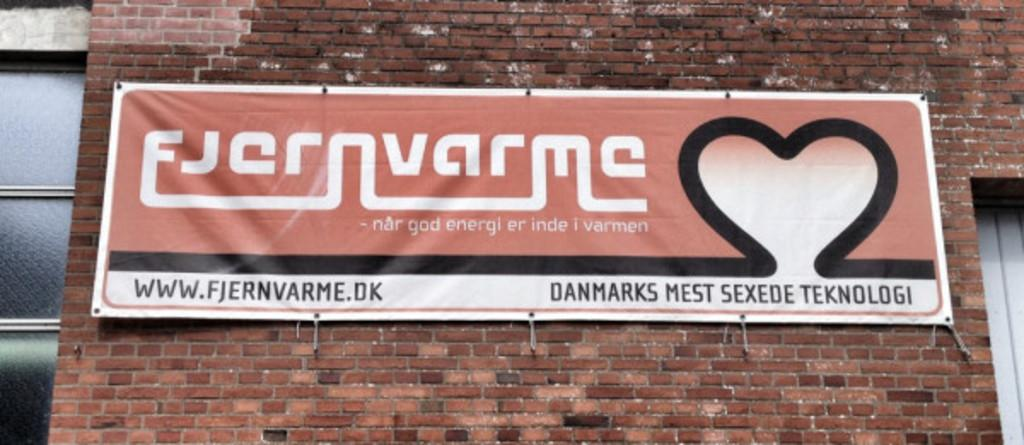What type of structure is present in the image? There is a building in the image. Can you describe any additional features on the building? There is a banner on a brick wall in the image. What month is it in the image? The month cannot be determined from the image, as there is no reference to a specific time or season. Can you see the ocean in the image? The ocean is not visible in the image; it only features a building and a banner on a brick wall. 